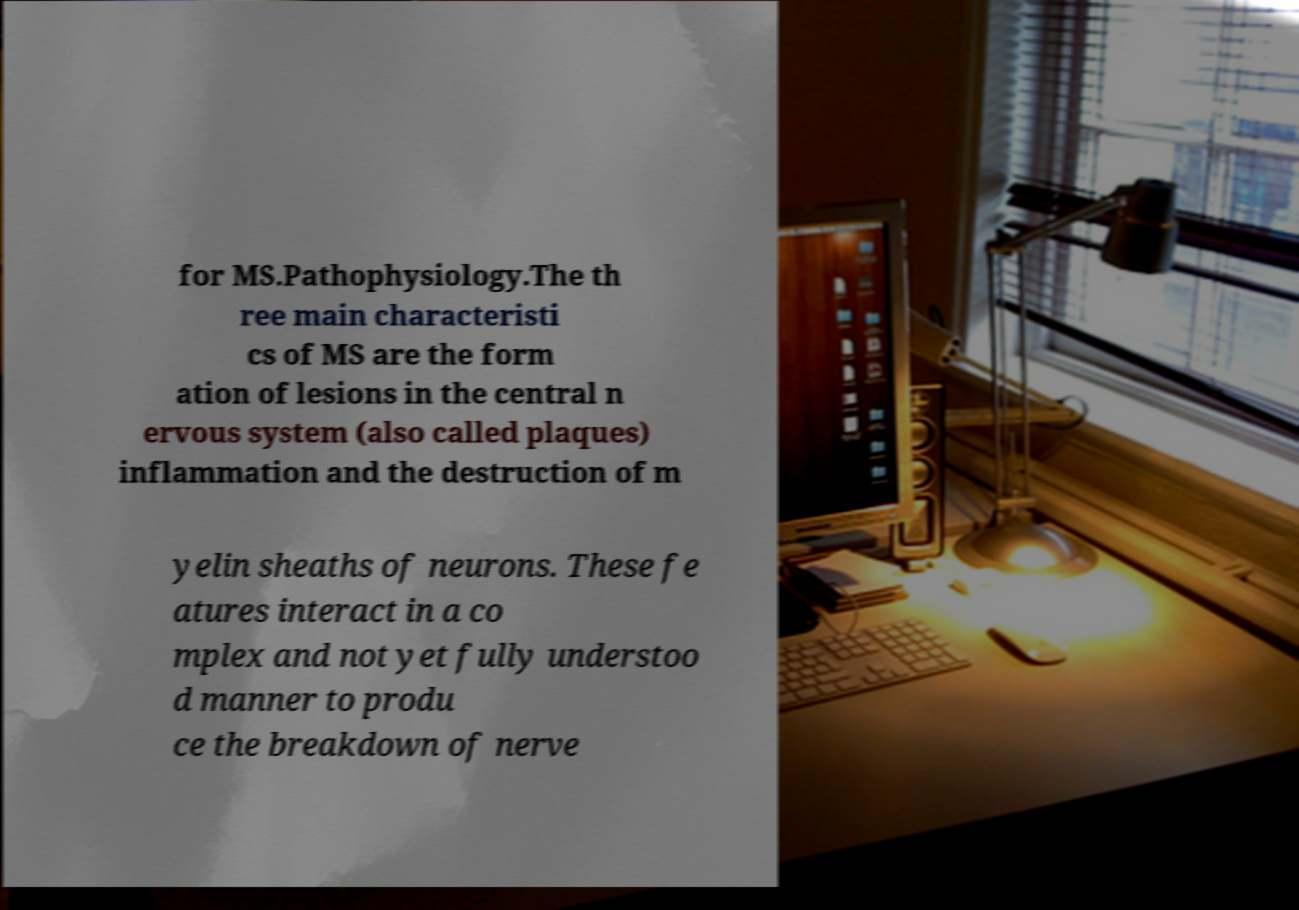For documentation purposes, I need the text within this image transcribed. Could you provide that? for MS.Pathophysiology.The th ree main characteristi cs of MS are the form ation of lesions in the central n ervous system (also called plaques) inflammation and the destruction of m yelin sheaths of neurons. These fe atures interact in a co mplex and not yet fully understoo d manner to produ ce the breakdown of nerve 